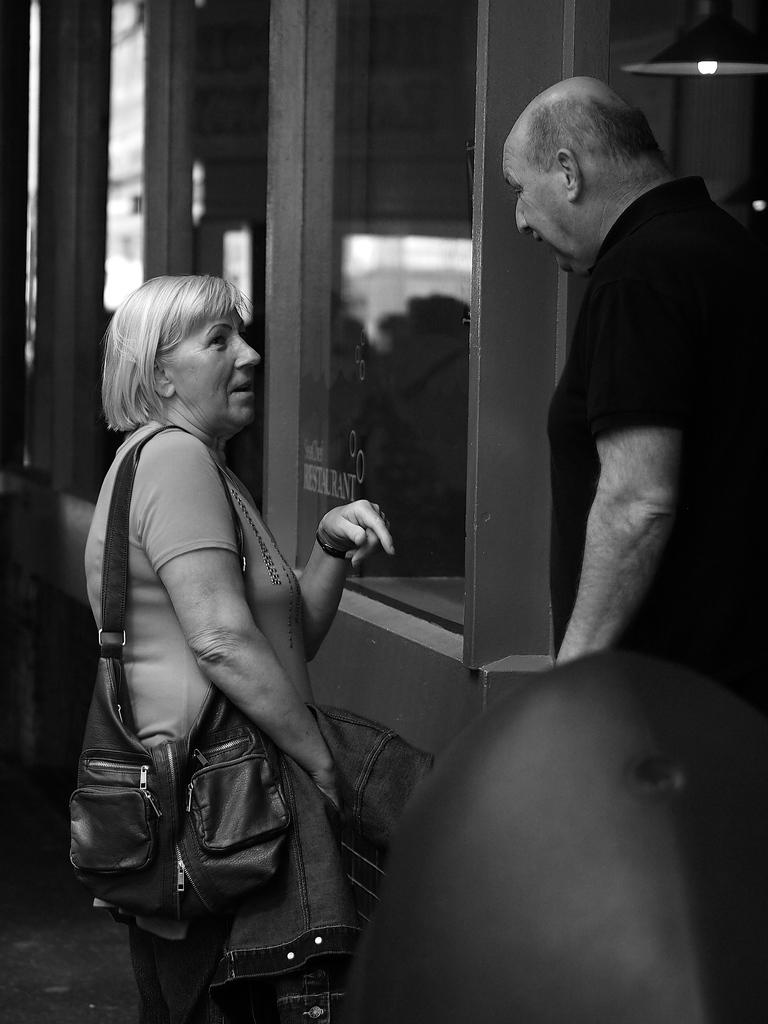What is the color scheme of the image? The image is black and white. Where is the man located in the image? The man is on the right side of the image. What can be seen on the right side of the image? There is light on the right side of the image. Where is the woman located in the image? The woman is on the left side of the image. What is visible in the background of the image? There are windows in the background of the image. What type of jewel is the man holding in the image? There is no jewel present in the image; it is a black and white image with a man and a woman in different positions. 